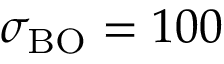<formula> <loc_0><loc_0><loc_500><loc_500>\sigma _ { B O } = 1 0 0 \</formula> 